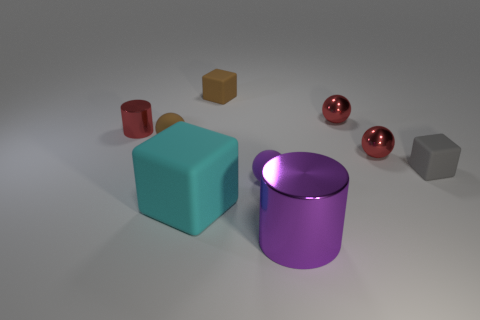Subtract all green balls. Subtract all cyan cylinders. How many balls are left? 4 Add 1 big rubber things. How many objects exist? 10 Subtract all cubes. How many objects are left? 6 Add 2 small rubber cubes. How many small rubber cubes exist? 4 Subtract 0 brown cylinders. How many objects are left? 9 Subtract all blue balls. Subtract all tiny brown matte cubes. How many objects are left? 8 Add 9 large matte blocks. How many large matte blocks are left? 10 